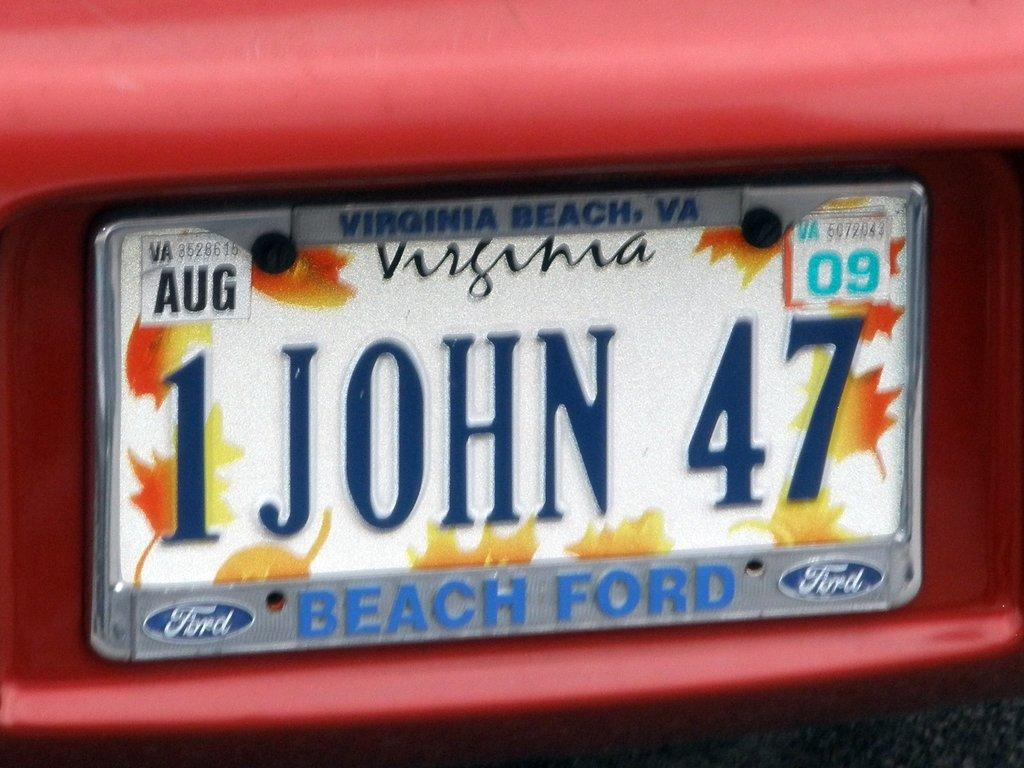What is the main object in the image? There is a board in the image. What is written on the board? The board has text and numbers written on it. What is the board placed on? The board is on an object. What is the color of the object the board is on? The object is red in color. What type of linen is draped over the board in the image? There is no linen present in the image, and it is not draped over the board. What sound can be heard in the image due to the thunder? There is no thunder present in the image, so no such sound can be heard. 